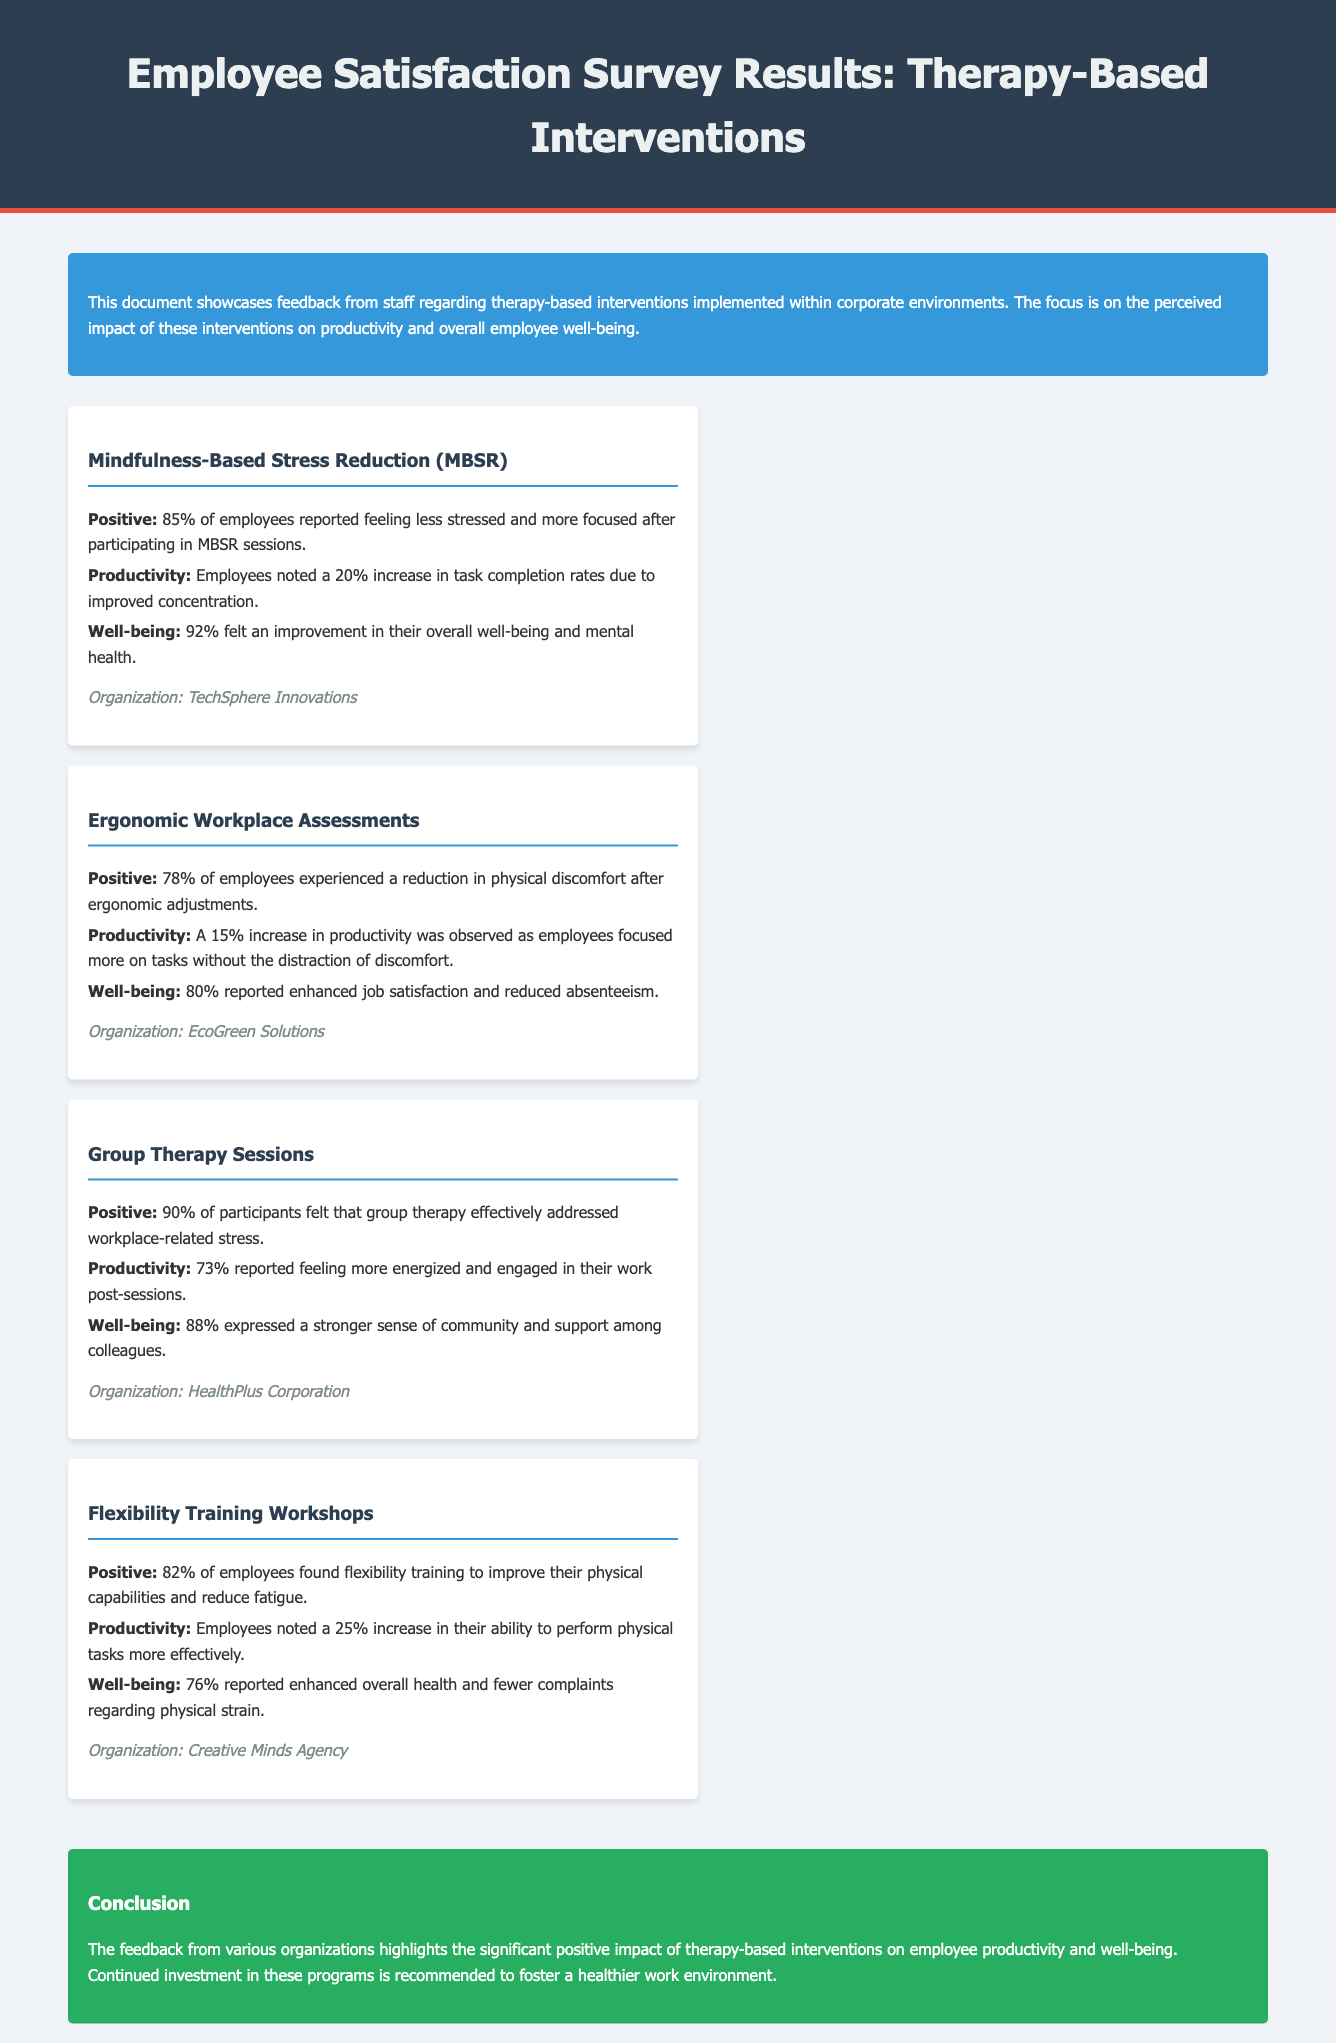What percentage of employees reported feeling less stressed after MBSR? The document states that 85% of employees reported feeling less stressed after participating in MBSR sessions.
Answer: 85% What was the increase in task completion rates due to MBSR? The document mentions a 20% increase in task completion rates linked to MBSR due to improved concentration.
Answer: 20% Which intervention had the highest reported improvement in well-being? The document indicates that 92% felt an improvement in overall well-being from the MBSR sessions, which is the highest among the interventions.
Answer: MBSR What organization implemented the Ergonomic Workplace Assessments? The document specifies that EcoGreen Solutions conducted the Ergonomic Workplace Assessments.
Answer: EcoGreen Solutions What percentage of participants felt group therapy addressed workplace-related stress? According to the document, 90% of participants felt that group therapy effectively addressed workplace-related stress.
Answer: 90% How did flexibility training impact the ability to perform physical tasks? The document highlights a 25% increase in the ability to perform physical tasks more effectively due to flexibility training workshops.
Answer: 25% What was the reported job satisfaction improvement after ergonomic adjustments? The document states that 80% reported enhanced job satisfaction after ergonomic adjustments.
Answer: 80% Which intervention led to a stronger sense of community among colleagues? The document notes that group therapy sessions resulted in 88% expressing a stronger sense of community and support among colleagues.
Answer: Group Therapy Sessions What is the main conclusion drawn in the document? The conclusion emphasizes the significant positive impact of therapy-based interventions on employee productivity and well-being, recommending continued investment.
Answer: Continued investment in these programs 